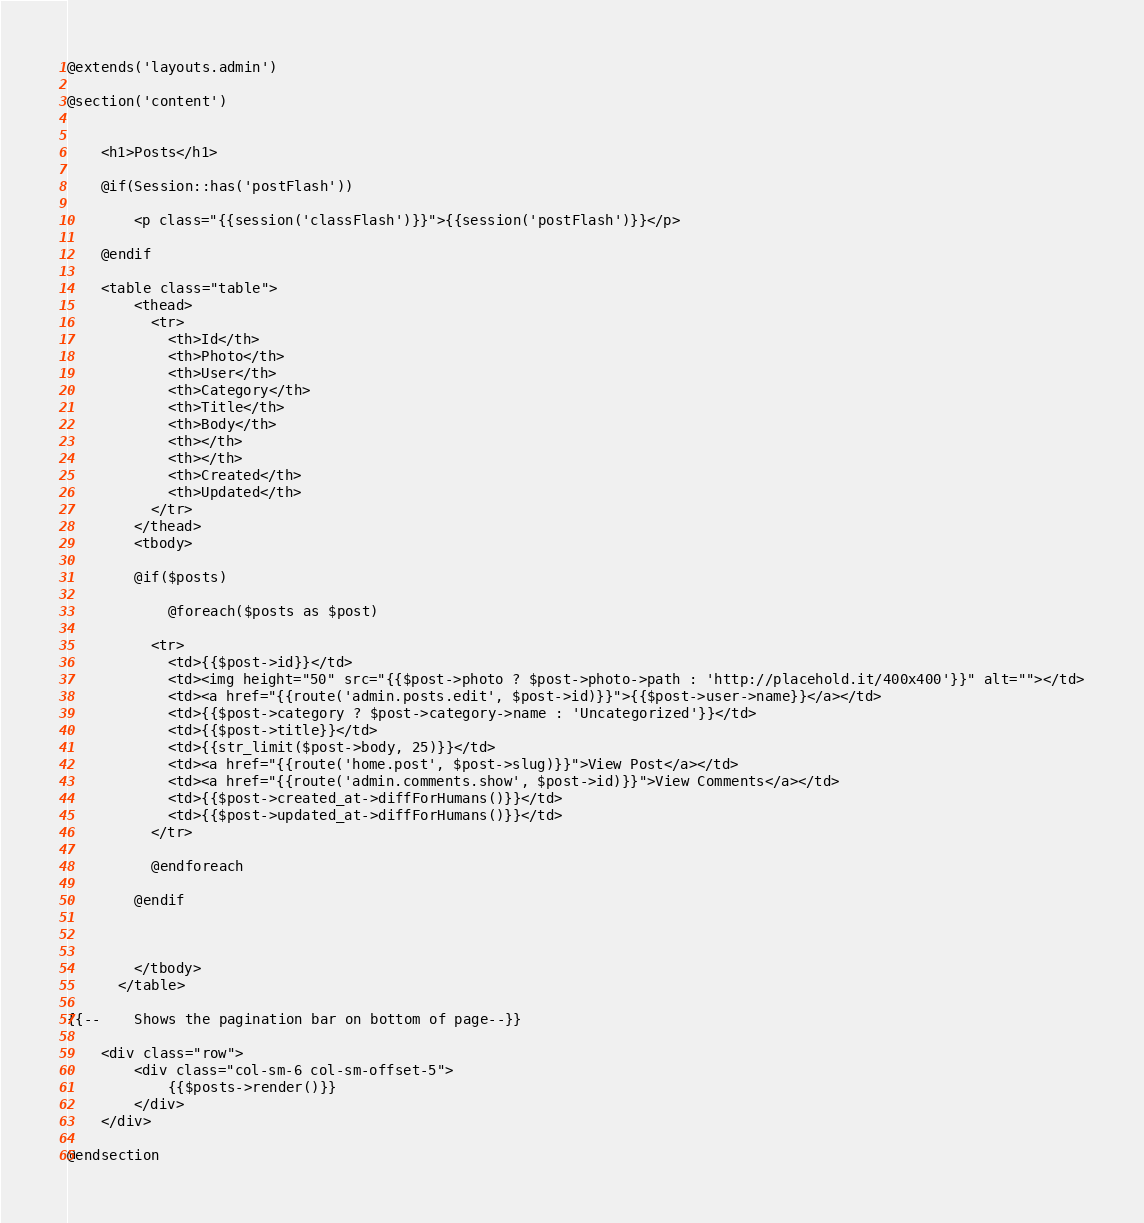<code> <loc_0><loc_0><loc_500><loc_500><_PHP_>@extends('layouts.admin')

@section('content')


    <h1>Posts</h1>

    @if(Session::has('postFlash'))

        <p class="{{session('classFlash')}}">{{session('postFlash')}}</p>

    @endif

    <table class="table">
        <thead>
          <tr>
            <th>Id</th>
            <th>Photo</th>
            <th>User</th>
            <th>Category</th>
            <th>Title</th>
            <th>Body</th>
            <th></th>
            <th></th>
            <th>Created</th>
            <th>Updated</th>
          </tr>
        </thead>
        <tbody>

        @if($posts)

            @foreach($posts as $post)

          <tr>
            <td>{{$post->id}}</td>
            <td><img height="50" src="{{$post->photo ? $post->photo->path : 'http://placehold.it/400x400'}}" alt=""></td>
            <td><a href="{{route('admin.posts.edit', $post->id)}}">{{$post->user->name}}</a></td>
            <td>{{$post->category ? $post->category->name : 'Uncategorized'}}</td>
            <td>{{$post->title}}</td>
            <td>{{str_limit($post->body, 25)}}</td>
            <td><a href="{{route('home.post', $post->slug)}}">View Post</a></td>
            <td><a href="{{route('admin.comments.show', $post->id)}}">View Comments</a></td>
            <td>{{$post->created_at->diffForHumans()}}</td>
            <td>{{$post->updated_at->diffForHumans()}}</td>
          </tr>

          @endforeach

        @endif



        </tbody>
      </table>

{{--    Shows the pagination bar on bottom of page--}}

    <div class="row">
        <div class="col-sm-6 col-sm-offset-5">
            {{$posts->render()}}
        </div>
    </div>

@endsection</code> 